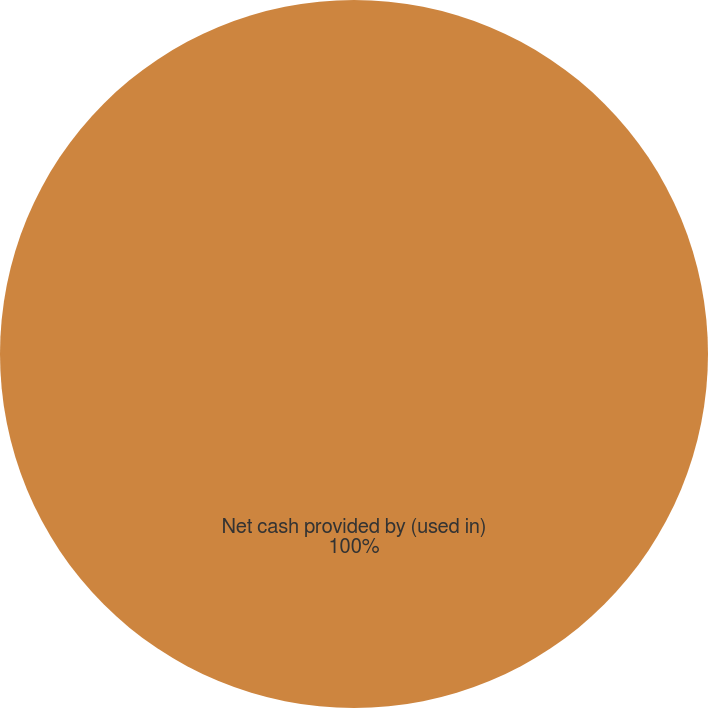<chart> <loc_0><loc_0><loc_500><loc_500><pie_chart><fcel>Net cash provided by (used in)<nl><fcel>100.0%<nl></chart> 